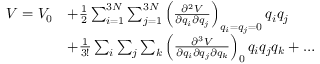<formula> <loc_0><loc_0><loc_500><loc_500>\begin{array} { r l } { V = V _ { 0 } } & { + \frac { 1 } { 2 } \sum _ { i = 1 } ^ { 3 N } \sum _ { j = 1 } ^ { 3 N } \left ( \frac { \partial ^ { 2 } V } { \partial q _ { i } \partial q _ { j } } \right ) _ { q _ { i } = q _ { j } = 0 } q _ { i } q _ { j } } \\ & { + \frac { 1 } { 3 ! } \sum _ { i } \sum _ { j } \sum _ { k } \left ( \frac { \partial ^ { 3 } V } { \partial q _ { i } \partial q _ { j } \partial q _ { k } } \right ) _ { 0 } q _ { i } q _ { j } q _ { k } + \dots } \end{array}</formula> 